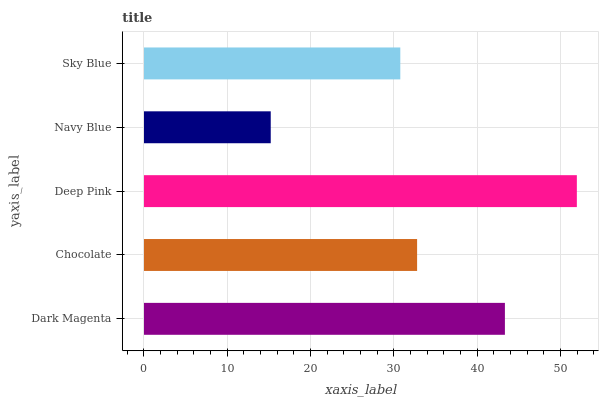Is Navy Blue the minimum?
Answer yes or no. Yes. Is Deep Pink the maximum?
Answer yes or no. Yes. Is Chocolate the minimum?
Answer yes or no. No. Is Chocolate the maximum?
Answer yes or no. No. Is Dark Magenta greater than Chocolate?
Answer yes or no. Yes. Is Chocolate less than Dark Magenta?
Answer yes or no. Yes. Is Chocolate greater than Dark Magenta?
Answer yes or no. No. Is Dark Magenta less than Chocolate?
Answer yes or no. No. Is Chocolate the high median?
Answer yes or no. Yes. Is Chocolate the low median?
Answer yes or no. Yes. Is Deep Pink the high median?
Answer yes or no. No. Is Sky Blue the low median?
Answer yes or no. No. 